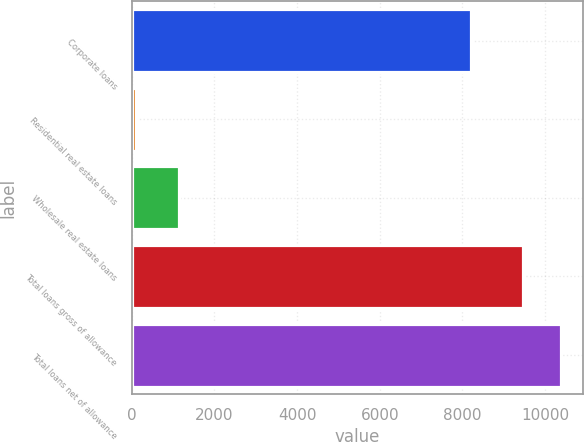<chart> <loc_0><loc_0><loc_500><loc_500><bar_chart><fcel>Corporate loans<fcel>Residential real estate loans<fcel>Wholesale real estate loans<fcel>Total loans gross of allowance<fcel>Total loans net of allowance<nl><fcel>8200<fcel>114<fcel>1144<fcel>9458<fcel>10392.4<nl></chart> 